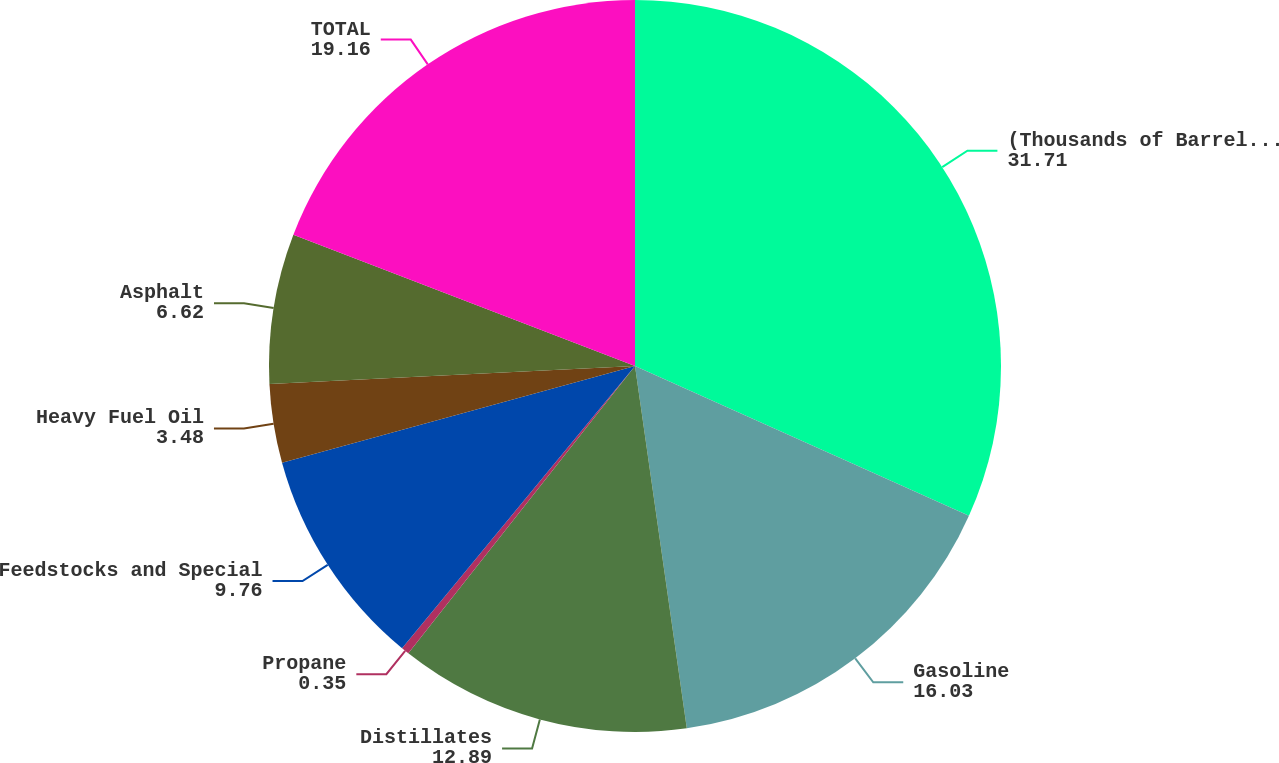Convert chart to OTSL. <chart><loc_0><loc_0><loc_500><loc_500><pie_chart><fcel>(Thousands of Barrels per Day)<fcel>Gasoline<fcel>Distillates<fcel>Propane<fcel>Feedstocks and Special<fcel>Heavy Fuel Oil<fcel>Asphalt<fcel>TOTAL<nl><fcel>31.71%<fcel>16.03%<fcel>12.89%<fcel>0.35%<fcel>9.76%<fcel>3.48%<fcel>6.62%<fcel>19.16%<nl></chart> 